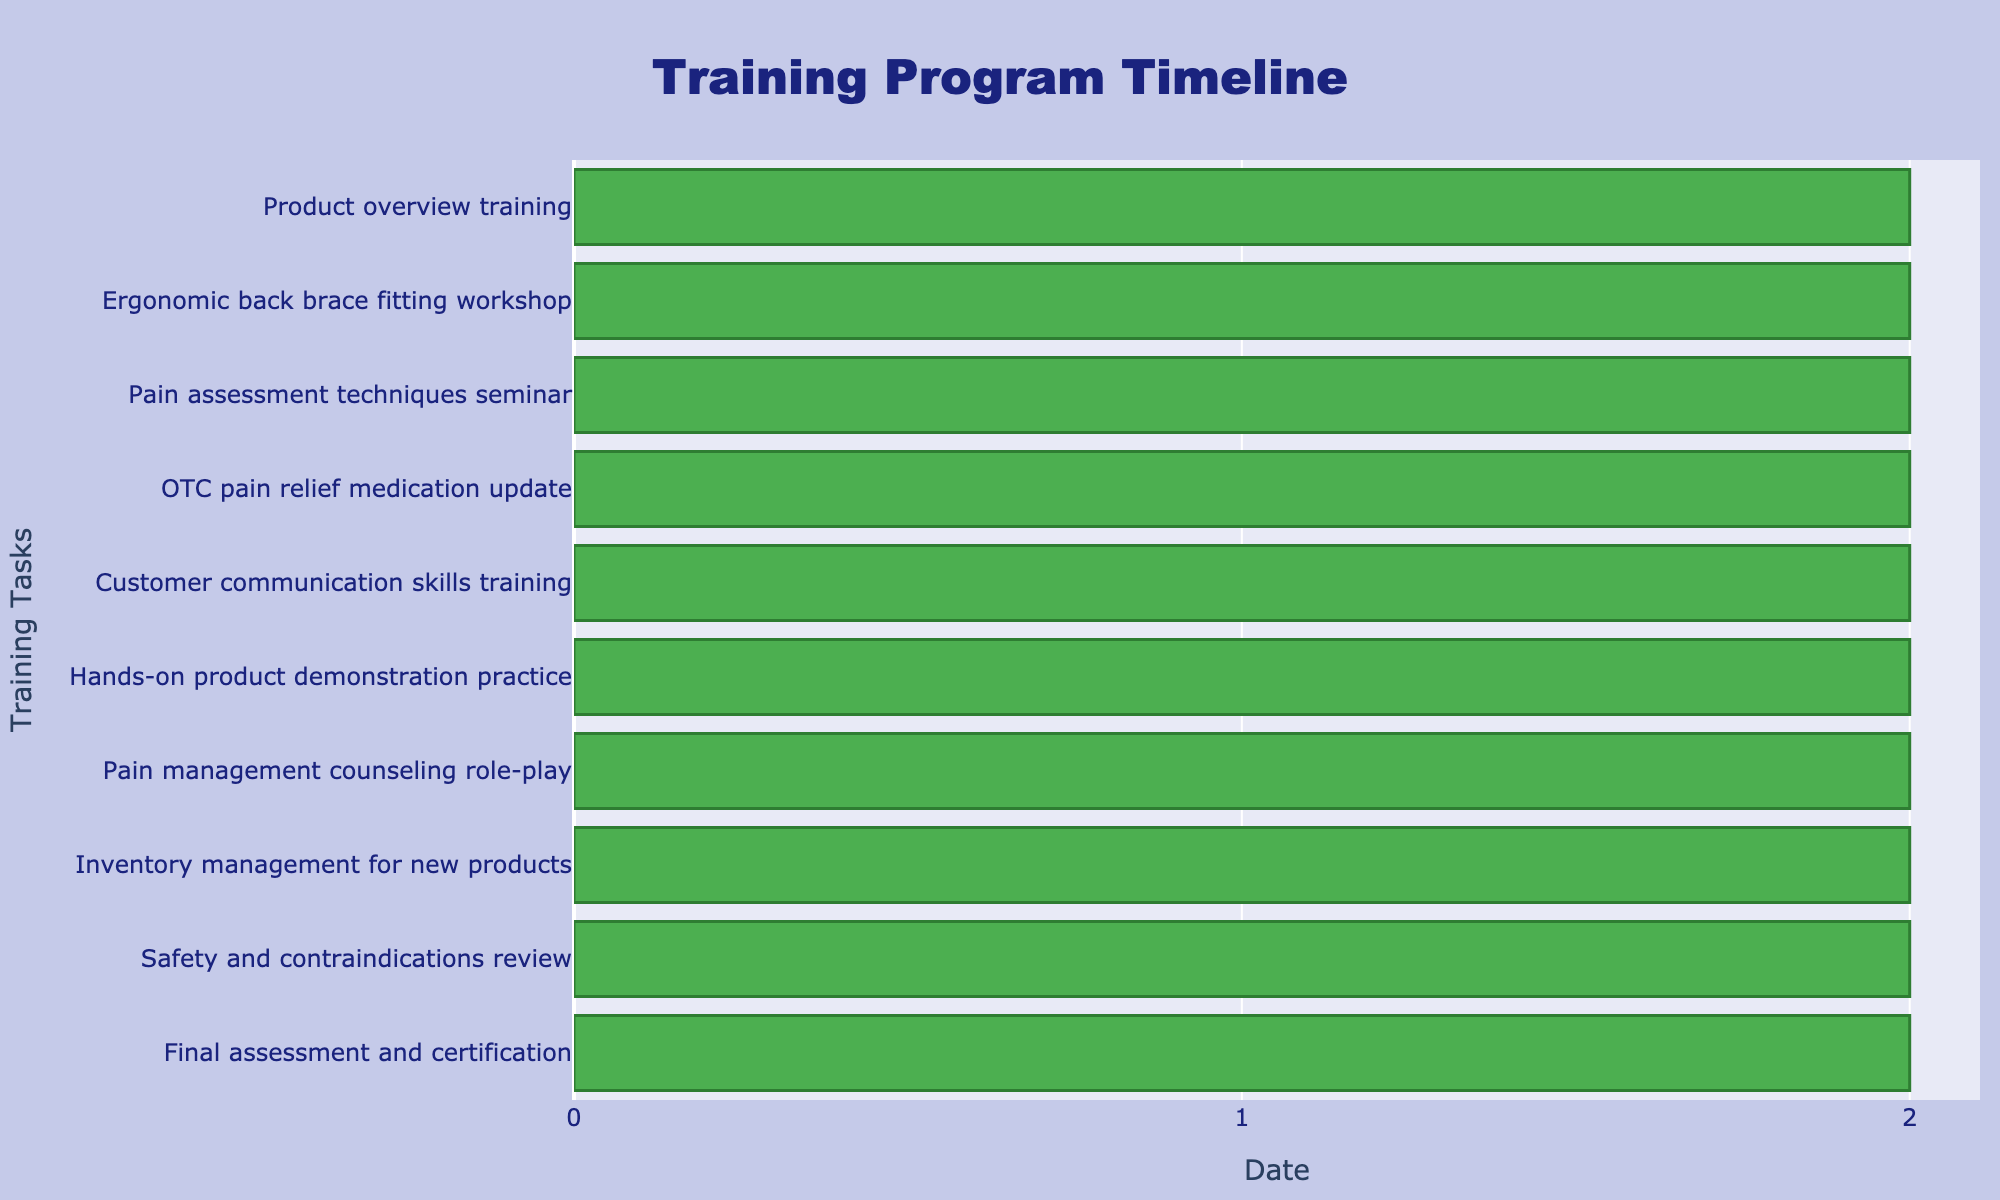What is the title of the chart? The title of the chart is displayed at the top of the figure. It reads "Training Program Timeline".
Answer: Training Program Timeline How many training tasks are shown in the Gantt chart? To determine the number of training tasks, count the number of horizontal bars. Each bar represents a task in the timeline. There are 10 horizontal bars, so there are 10 training tasks.
Answer: 10 Which training task starts on 2023-06-13? Locate the task with a start date of 2023-06-13 by looking at the horizontal bars and their associated dates. The task "Customer communication skills training" starts on 2023-06-13.
Answer: Customer communication skills training What is the duration of the "Ergonomic back brace fitting workshop"? The duration of each task is indicated in the Gantt chart. For the "Ergonomic back brace fitting workshop", we need to check its start date (2023-06-04) and end date (2023-06-06). The duration is calculated as the difference between the end date and the start date, which is 2 days.
Answer: 2 days Which task ends before the "Pain assessment techniques seminar" starts? The "Pain assessment techniques seminar" starts on 2023-06-07. Look for the task that ends before this date. The "Ergonomic back brace fitting workshop" ends on 2023-06-06, which is the day before.
Answer: Ergonomic back brace fitting workshop How long does the entire training program last? To find the total duration, note the start date of the first task and the end date of the last task. The program starts on 2023-06-01 and ends on 2023-06-30. The duration is the difference between these dates, which is 29 days.
Answer: 29 days Which task has the longest duration? To identify the task with the longest duration, compare the lengths of the horizontal bars. "Final assessment and certification" lasts from 2023-06-28 to 2023-06-30, which is 3 days. All other tasks last for 2 days, making "Final assessment and certification" the longest.
Answer: Final assessment and certification What's the average duration of all tasks? To find the average duration, sum the durations of all tasks and divide by the number of tasks. Each task duration is 2 days except for "Final assessment and certification" which is 3 days. The total duration is (9 * 2) + 3 = 21 days. The average duration is 21 days / 10 tasks = 2.1 days.
Answer: 2.1 days What task is scheduled immediately before "Inventory management for new products"? "Inventory management for new products" starts on 2023-06-22. The task immediately before this one is "Pain management counseling role-play", which ends on 2023-06-21.
Answer: Pain management counseling role-play What are the start and end dates of the "Safety and contraindications review"? Locate the "Safety and contraindications review" task and check its start and end dates. It starts on 2023-06-25 and ends on 2023-06-27.
Answer: 2023-06-25 to 2023-06-27 